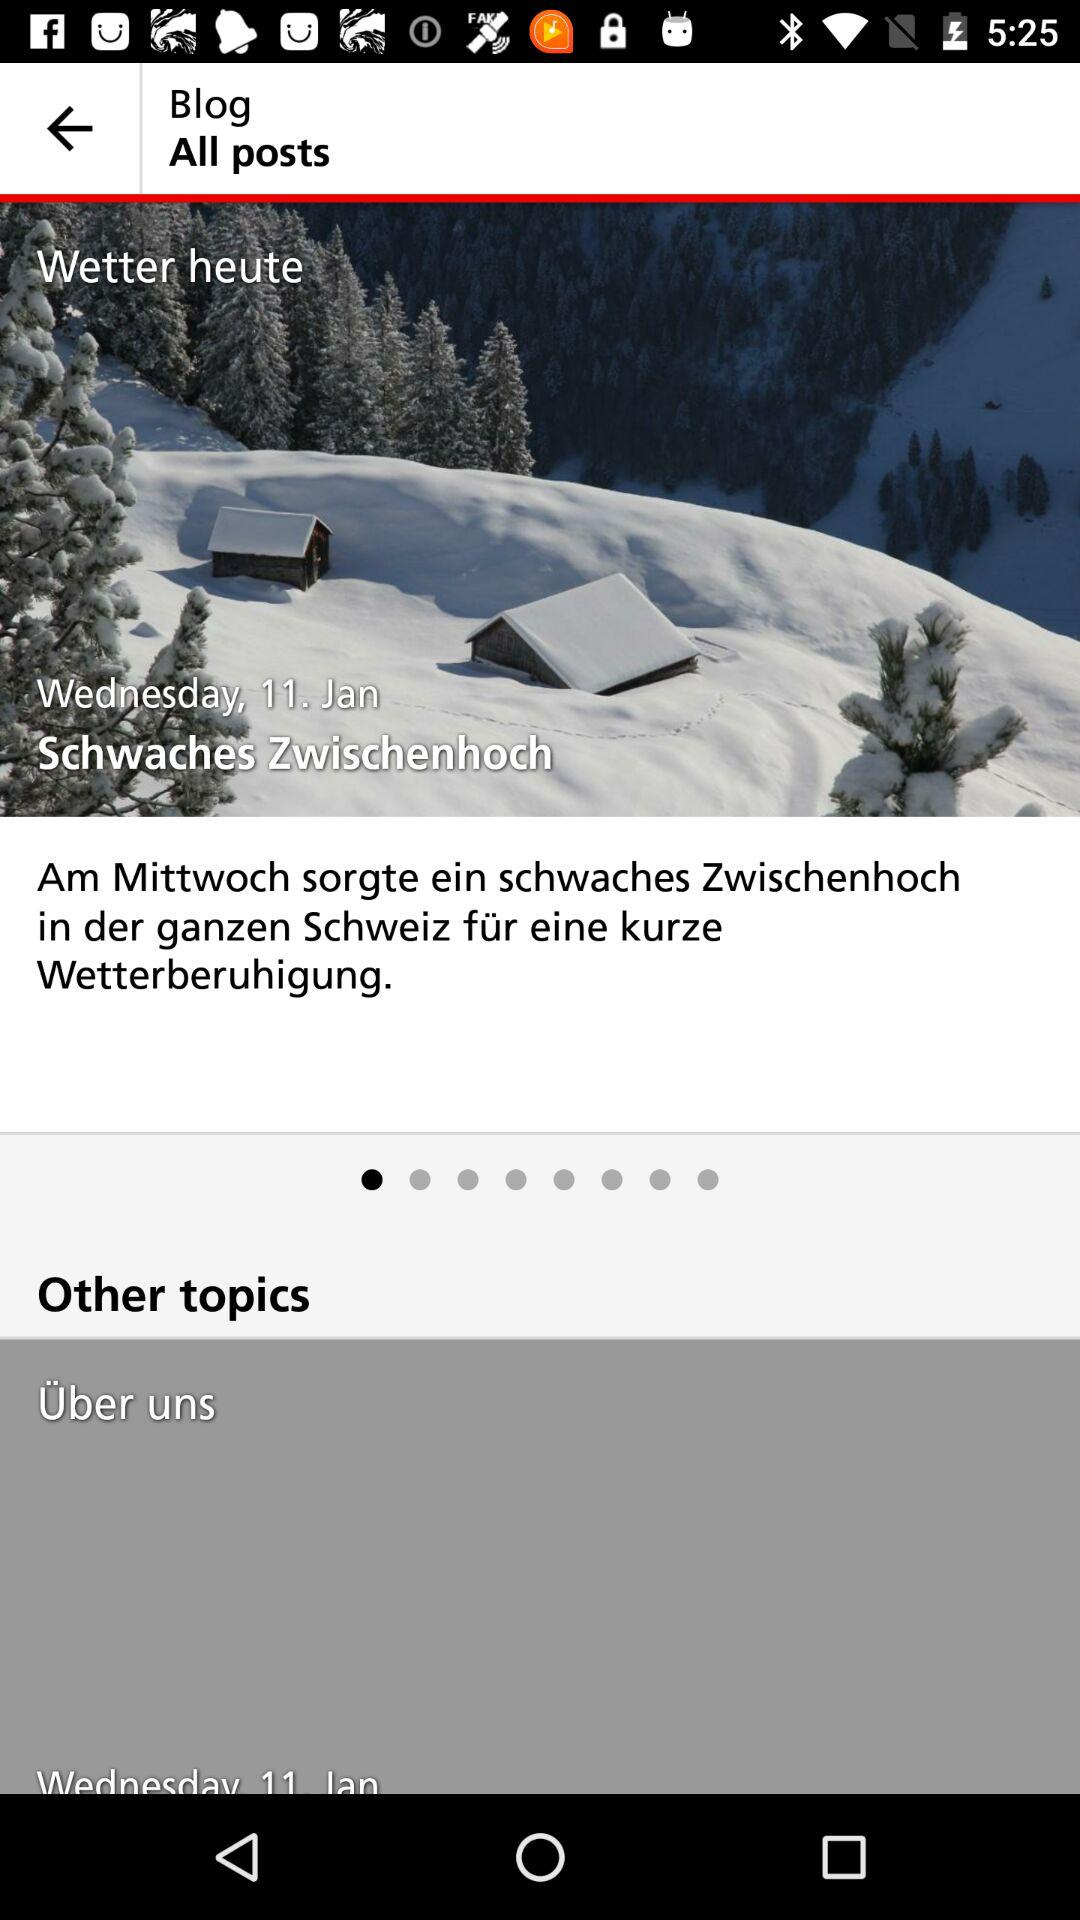What is the date? The date is Wednesday, January 11. 